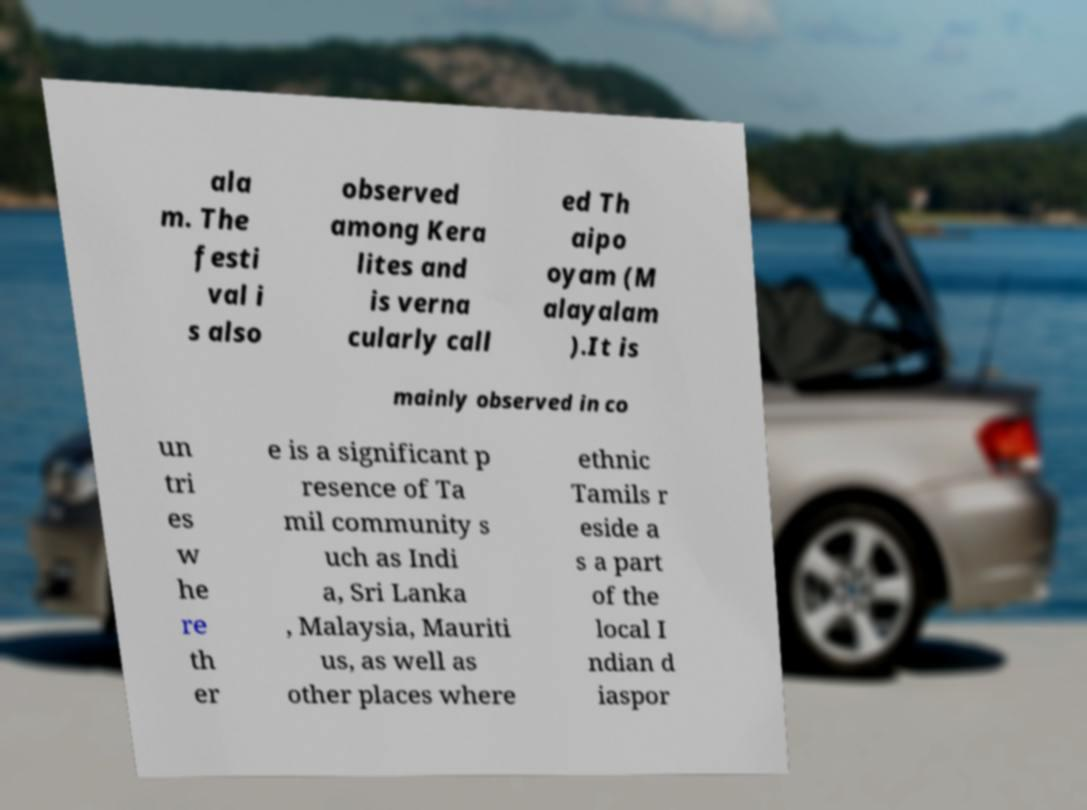Could you extract and type out the text from this image? ala m. The festi val i s also observed among Kera lites and is verna cularly call ed Th aipo oyam (M alayalam ).It is mainly observed in co un tri es w he re th er e is a significant p resence of Ta mil community s uch as Indi a, Sri Lanka , Malaysia, Mauriti us, as well as other places where ethnic Tamils r eside a s a part of the local I ndian d iaspor 